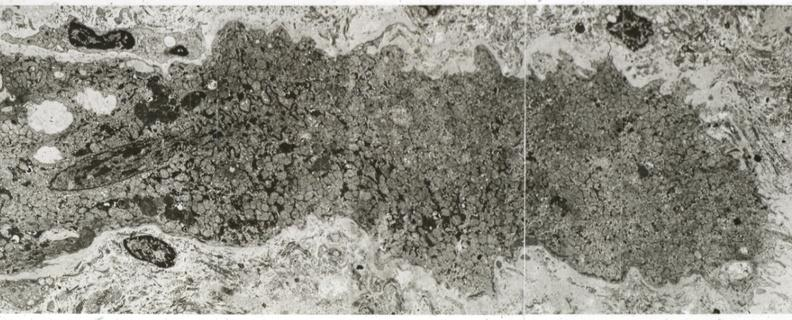does typical tuberculous exudate show advanced myofiber atrophy?
Answer the question using a single word or phrase. No 